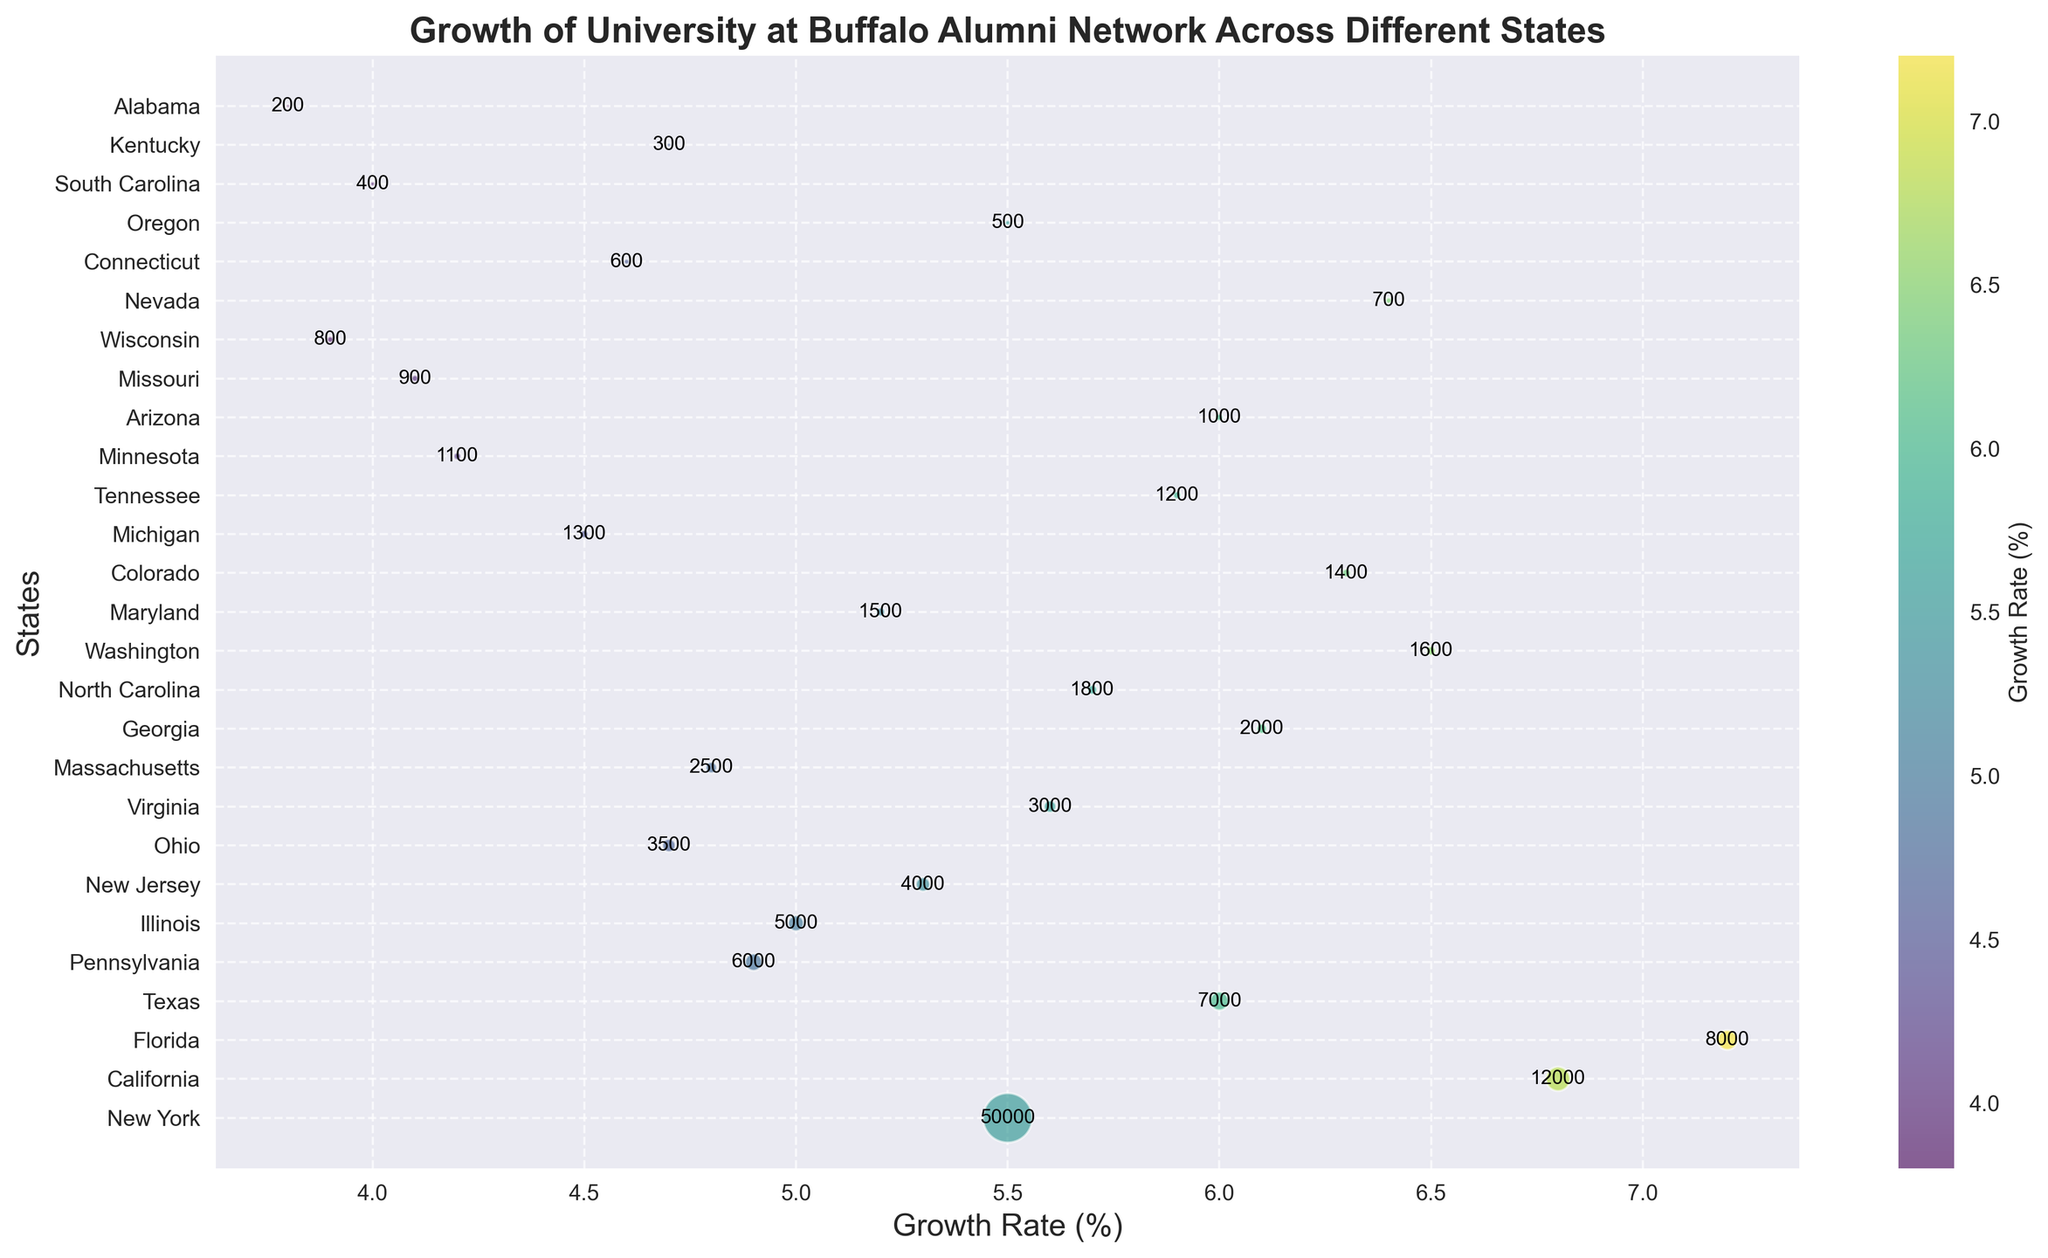Which state has the highest alumni growth rate? Look at the y-axis labels for the state names, and find the highest value on the x-axis, which represents the growth rate. Florida has the highest growth rate at 7.2%.
Answer: Florida Which state has the largest alumni count? Look at the size of the bubbles because larger bubbles indicate a larger alumni count. New York has the largest bubble, which corresponds to an alumni count of 50,000.
Answer: New York Which state has an alumni count of 1600? Check the text annotations near the bubbles; the state with an alumni count of 1600 is Washington.
Answer: Washington Compare the alumni growth rates of California and Texas. Which one is higher? Identify the positions of California and Texas on the x-axis, representing the growth rate. California is at 6.8%, while Texas is at 6.0%. Therefore, California has a higher growth rate.
Answer: California What is the average alumni growth rate of the states with more than 10,000 alumni? First, identify states with more than 10,000 alumni: New York (5.5%), California (6.8%). Then, calculate the average: (5.5% + 6.8%) / 2 = 6.15%.
Answer: 6.15% Which state has the smallest bubble, and what does it represent? Look for the smallest bubble on the plot; it corresponds to Alabama, which has the smallest alumni count of 200.
Answer: Alabama Is the alumni growth rate of Virginia more or less than 5.5%? Find the position of Virginia on the x-axis. It is at 5.6%, which is more than 5.5%.
Answer: More Identify the states with a growth rate between 6% and 7%. Check the bubbles positioned between 6% and 7% on the x-axis: California (6.8%), Florida (7.2%), Texas (6.0%), Georgia (6.1%), Washington (6.5%), Colorado (6.3%), and Nevada (6.4%).
Answer: California, Florida, Texas, Georgia, Washington, Colorado, Nevada What is the difference in alumni growth rates between Illinois and New Jersey? Find Illinois and New Jersey on the x-axis to compare their growth rates. Illinois is at 5.0% and New Jersey is at 5.3%. The difference is 5.3% - 5.0% = 0.3%.
Answer: 0.3% How many states have an alumni count greater than 5000? List them. Count the bubbles with numbers greater than 5000. The states are New York, California, Florida, Texas, Pennsylvania, and Illinois.
Answer: Six: New York, California, Florida, Texas, Pennsylvania, Illinois 